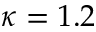Convert formula to latex. <formula><loc_0><loc_0><loc_500><loc_500>\kappa = 1 . 2</formula> 